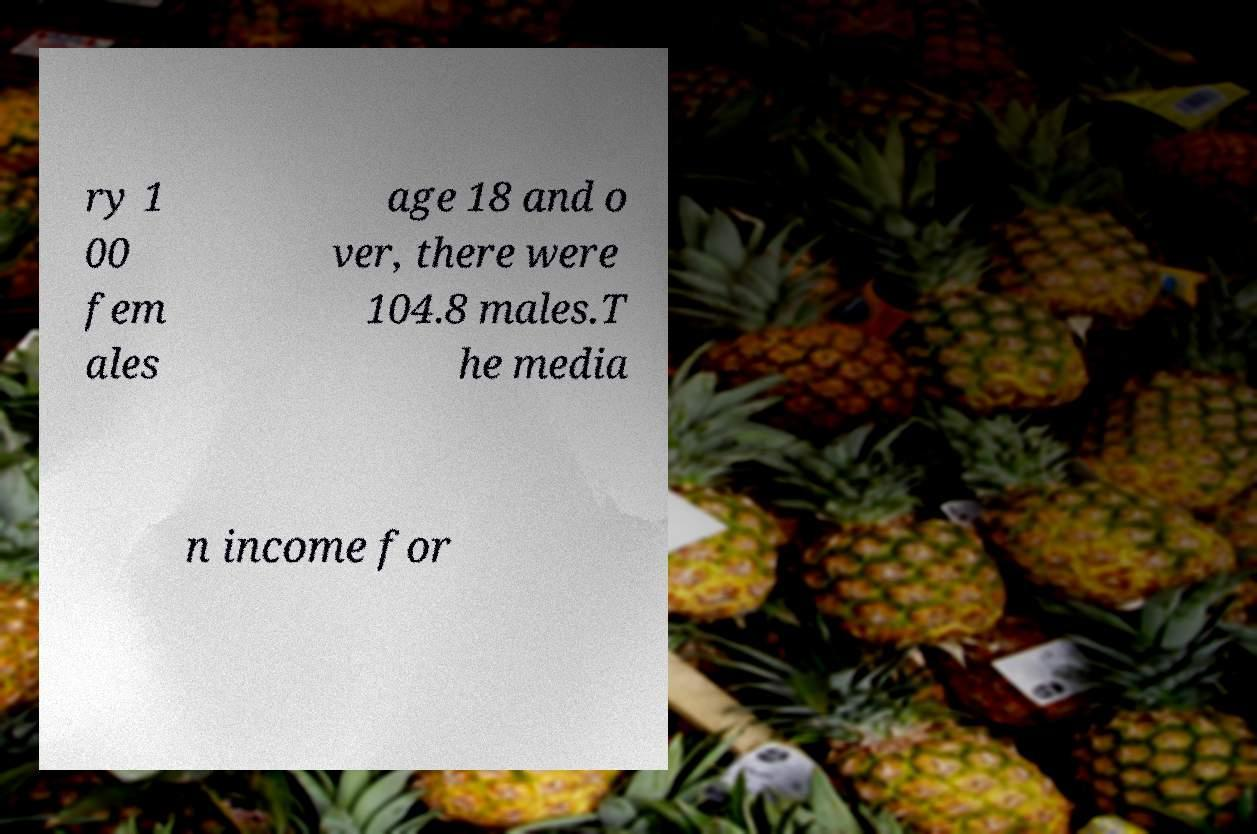Can you accurately transcribe the text from the provided image for me? ry 1 00 fem ales age 18 and o ver, there were 104.8 males.T he media n income for 